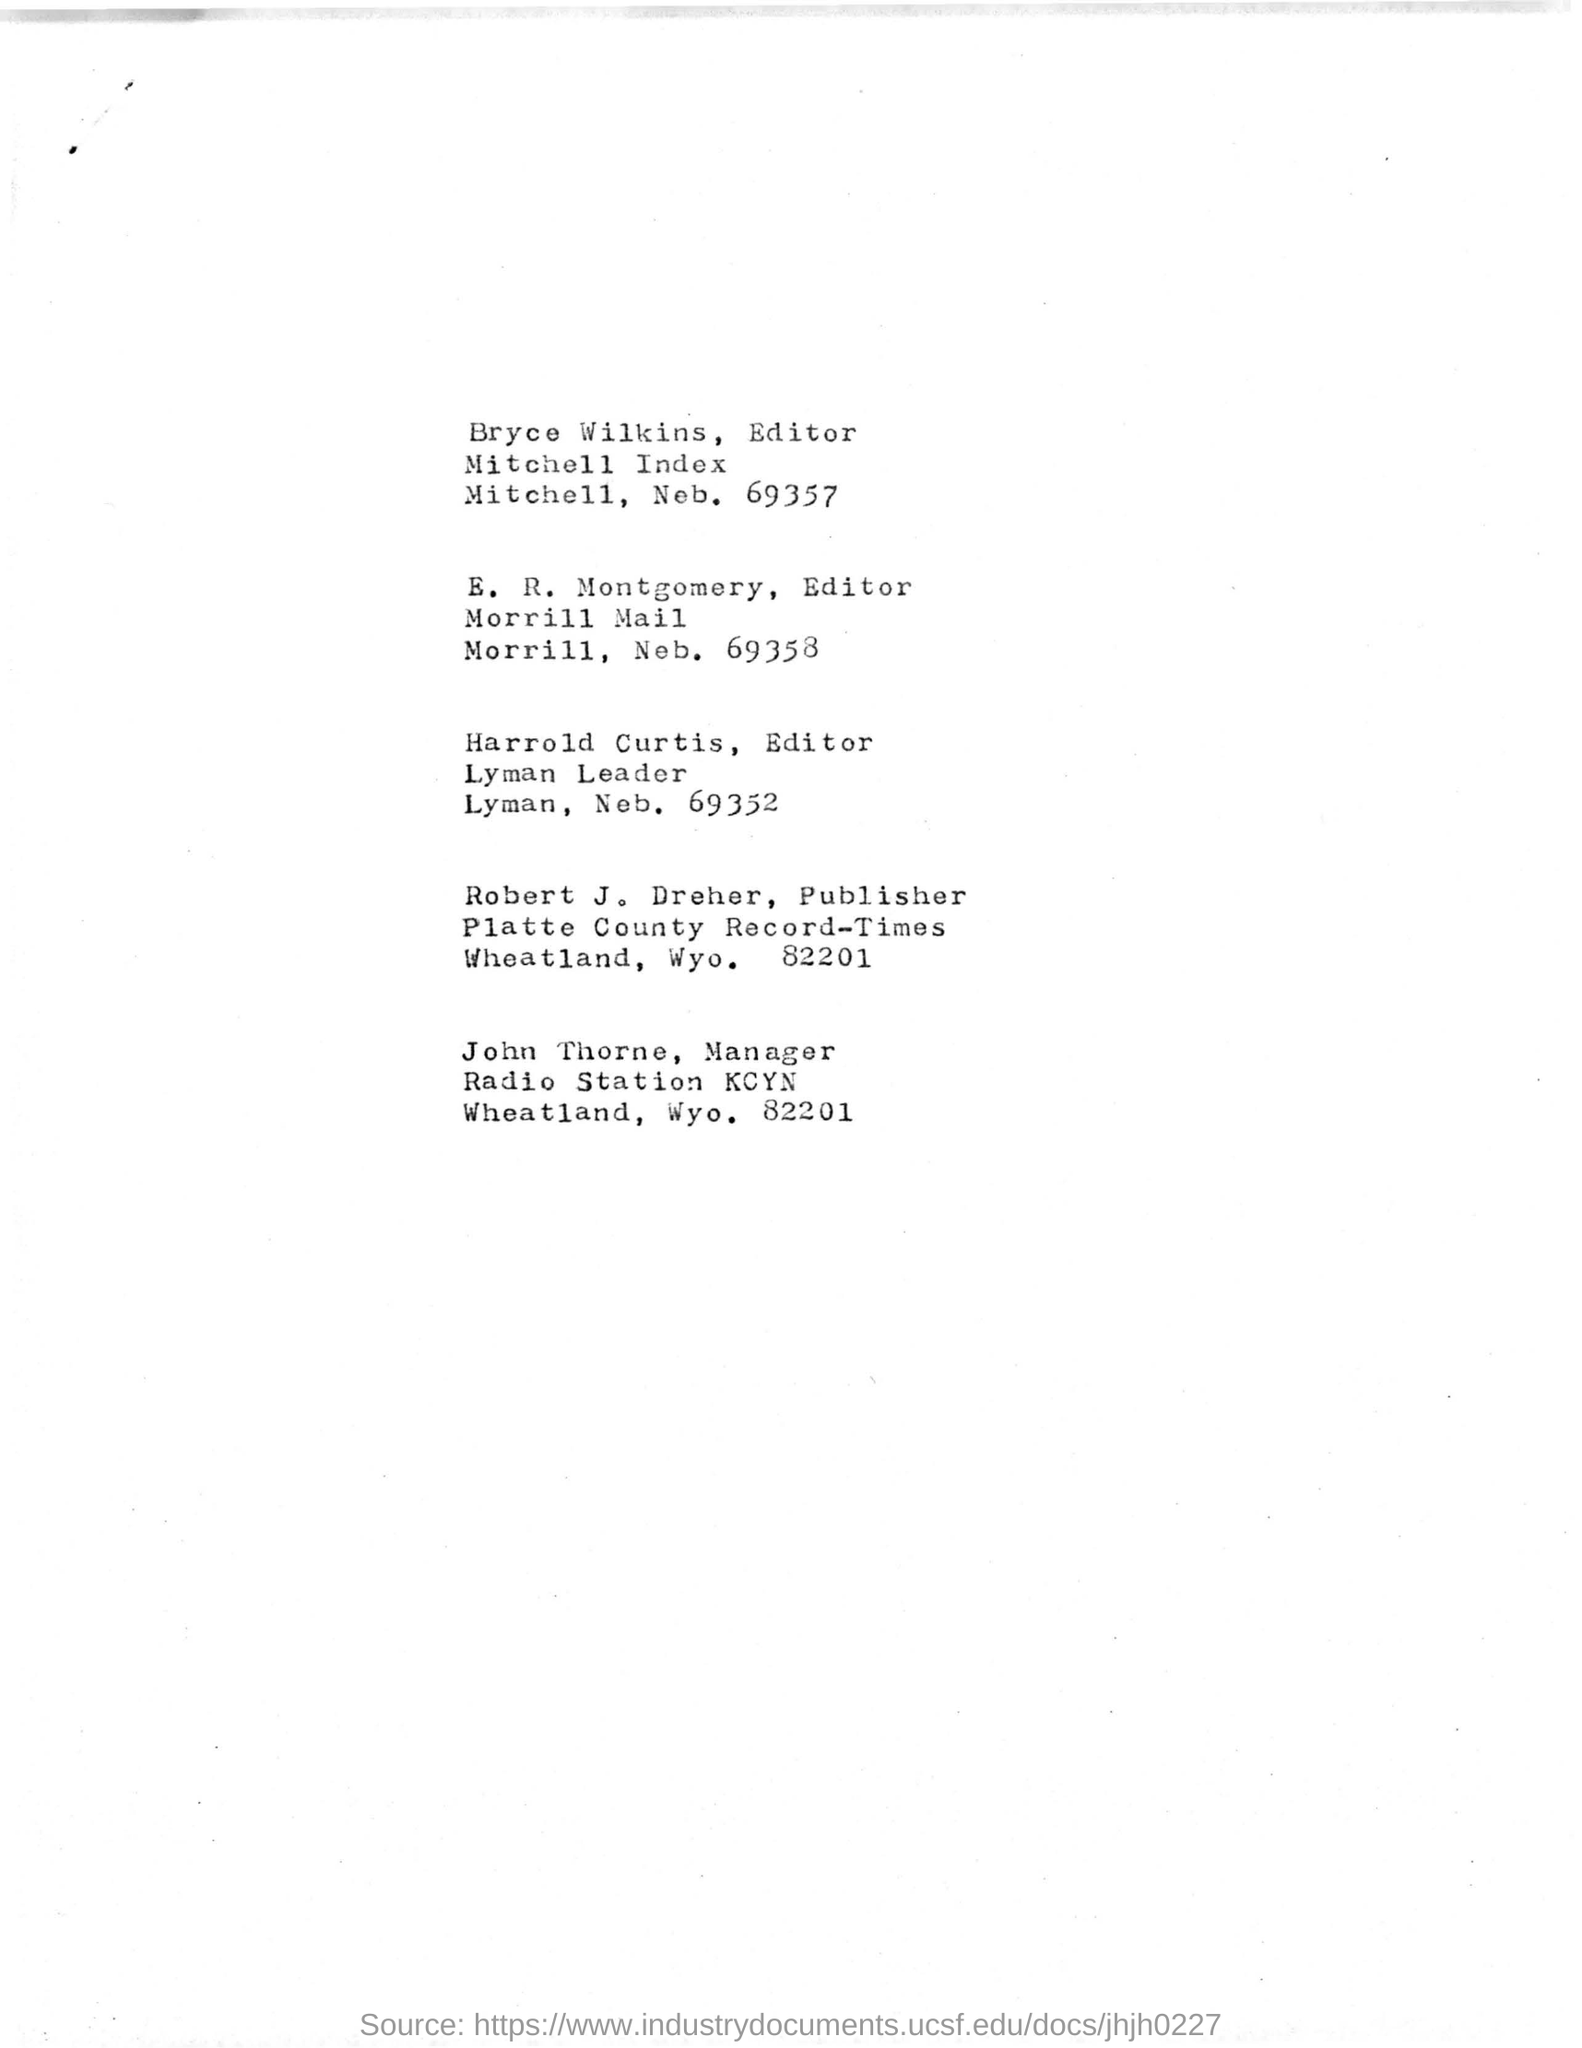Give some essential details in this illustration. The designation of E. R. Montgomery is Editor. Bryce Wilkins is the editor of the Mitchell Index. The Platte County Record-Times is located in Wheatland, Wyoming, at the address of 82201. 